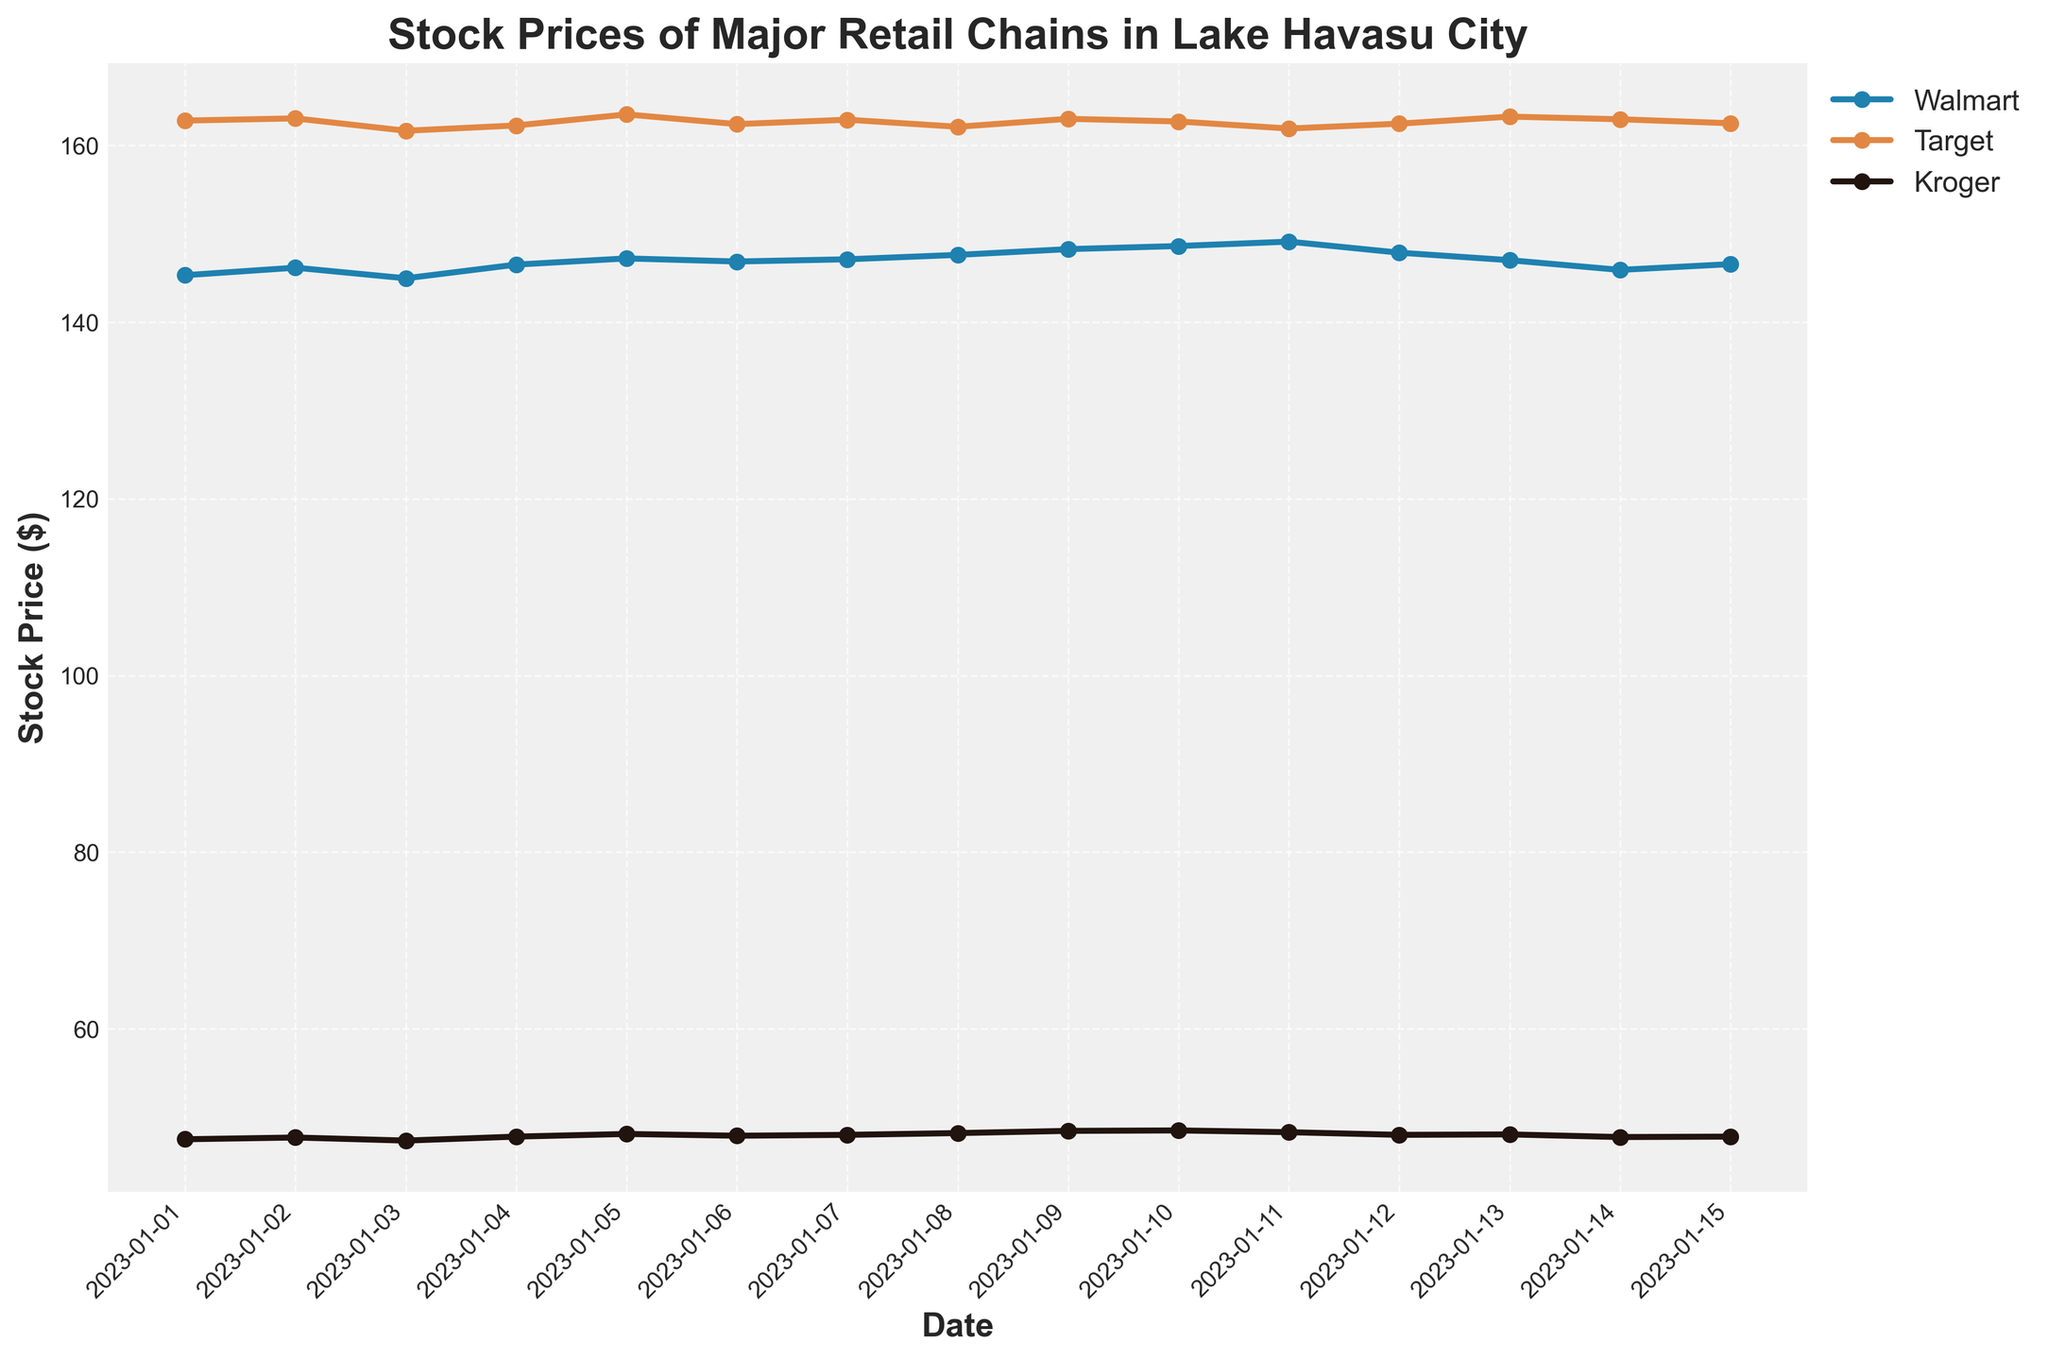What is the title of the plot? The title of the plot is usually found at the top of the figure and provides an overview of what the data represents. In this figure, the title gives context about the data being displayed.
Answer: Stock Prices of Major Retail Chains in Lake Havasu City How many companies' stock prices are shown in the plot? The plot displays the stock prices for each company using different colored lines and markers. By counting the number of distinct lines in the legend, we can determine the number of companies.
Answer: Three Which company has the highest stock price on January 03, 2023? We look at the data points for January 03, 2023, and compare the stock prices for each company. Walmart is at 144.95, Target is at 161.65, and Kroger is at 47.35.
Answer: Target What is the average stock price of Kroger from January 01 to January 15, 2023? To find the average, we add up all the Kroger stock prices and divide by the number of days. The sum is 47.50 + 47.70 + 47.35 + 47.80 + 48.10 + 47.90 + 48.00 + 48.20 + 48.45 + 48.50 + 48.30 + 48.00 + 48.05 + 47.75 + 47.80. The total sum is 715.40, and dividing by 15 days gives an average.
Answer: 47.69 Between January 05 and January 10, which company's stock price increased the most? We calculate the stock price change for each company between January 05 and January 10. For Walmart, it is 148.60 - 147.20 = 1.40. For Target, it is 162.70 - 163.50 = -0.80. For Kroger, it is 48.50 - 48.10 = 0.40.
Answer: Walmart On which date did Walmart have its highest stock price, and what was it? By examining the Walmart line, we can see which date has the highest value. The highest point is on January 11, 2023.
Answer: January 11, 2023, at $149.10 Which company saw the most stable stock prices, using the variance in stock prices from January 01 to January 15? The variance in stock prices can be assessed by observing the spread of values for each company. Kroger's prices range from 47.35 to 48.50, Walmart from 144.95 to 149.10, and Target from 161.65 to 163.50. Kroger shows the least spread.
Answer: Kroger Did any company experience a downward trend? If so, which ones? A downward trend is identified by observing the slope of the plotted line over time. Target shows a slight downward trend from January 01 to January 11.
Answer: Target 